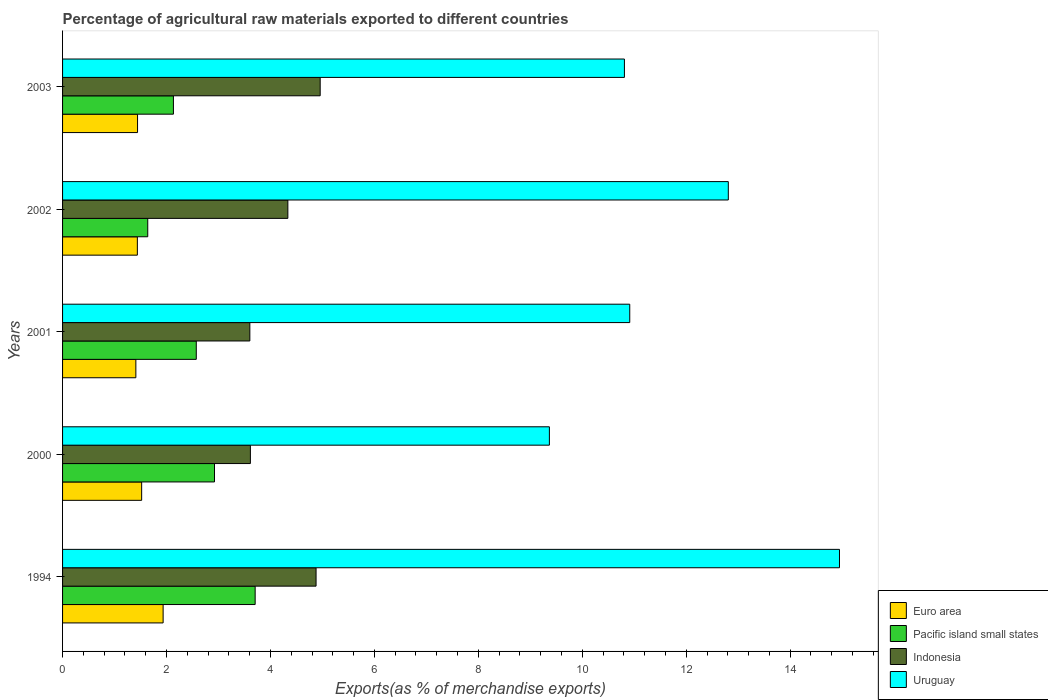How many different coloured bars are there?
Keep it short and to the point. 4. How many groups of bars are there?
Provide a succinct answer. 5. Are the number of bars per tick equal to the number of legend labels?
Keep it short and to the point. Yes. Are the number of bars on each tick of the Y-axis equal?
Offer a terse response. Yes. How many bars are there on the 5th tick from the top?
Make the answer very short. 4. What is the label of the 1st group of bars from the top?
Your answer should be compact. 2003. What is the percentage of exports to different countries in Uruguay in 2002?
Offer a very short reply. 12.81. Across all years, what is the maximum percentage of exports to different countries in Pacific island small states?
Your response must be concise. 3.71. Across all years, what is the minimum percentage of exports to different countries in Uruguay?
Your answer should be compact. 9.37. In which year was the percentage of exports to different countries in Pacific island small states minimum?
Give a very brief answer. 2002. What is the total percentage of exports to different countries in Indonesia in the graph?
Provide a succinct answer. 21.39. What is the difference between the percentage of exports to different countries in Indonesia in 1994 and that in 2001?
Your response must be concise. 1.27. What is the difference between the percentage of exports to different countries in Pacific island small states in 2001 and the percentage of exports to different countries in Indonesia in 2002?
Give a very brief answer. -1.76. What is the average percentage of exports to different countries in Euro area per year?
Your response must be concise. 1.55. In the year 2002, what is the difference between the percentage of exports to different countries in Indonesia and percentage of exports to different countries in Uruguay?
Your answer should be compact. -8.47. In how many years, is the percentage of exports to different countries in Indonesia greater than 2.4 %?
Offer a terse response. 5. What is the ratio of the percentage of exports to different countries in Pacific island small states in 1994 to that in 2003?
Provide a succinct answer. 1.74. Is the percentage of exports to different countries in Indonesia in 1994 less than that in 2001?
Your answer should be compact. No. What is the difference between the highest and the second highest percentage of exports to different countries in Indonesia?
Your response must be concise. 0.08. What is the difference between the highest and the lowest percentage of exports to different countries in Pacific island small states?
Give a very brief answer. 2.07. In how many years, is the percentage of exports to different countries in Indonesia greater than the average percentage of exports to different countries in Indonesia taken over all years?
Offer a very short reply. 3. What does the 3rd bar from the top in 2001 represents?
Keep it short and to the point. Pacific island small states. What does the 4th bar from the bottom in 2003 represents?
Give a very brief answer. Uruguay. How many years are there in the graph?
Offer a very short reply. 5. What is the difference between two consecutive major ticks on the X-axis?
Your answer should be compact. 2. Are the values on the major ticks of X-axis written in scientific E-notation?
Your answer should be compact. No. How many legend labels are there?
Make the answer very short. 4. What is the title of the graph?
Offer a terse response. Percentage of agricultural raw materials exported to different countries. Does "New Caledonia" appear as one of the legend labels in the graph?
Your response must be concise. No. What is the label or title of the X-axis?
Provide a succinct answer. Exports(as % of merchandise exports). What is the Exports(as % of merchandise exports) of Euro area in 1994?
Offer a terse response. 1.93. What is the Exports(as % of merchandise exports) in Pacific island small states in 1994?
Provide a succinct answer. 3.71. What is the Exports(as % of merchandise exports) in Indonesia in 1994?
Provide a short and direct response. 4.88. What is the Exports(as % of merchandise exports) of Uruguay in 1994?
Your response must be concise. 14.95. What is the Exports(as % of merchandise exports) in Euro area in 2000?
Ensure brevity in your answer.  1.52. What is the Exports(as % of merchandise exports) of Pacific island small states in 2000?
Give a very brief answer. 2.92. What is the Exports(as % of merchandise exports) of Indonesia in 2000?
Give a very brief answer. 3.61. What is the Exports(as % of merchandise exports) in Uruguay in 2000?
Ensure brevity in your answer.  9.37. What is the Exports(as % of merchandise exports) of Euro area in 2001?
Offer a very short reply. 1.41. What is the Exports(as % of merchandise exports) of Pacific island small states in 2001?
Make the answer very short. 2.57. What is the Exports(as % of merchandise exports) of Indonesia in 2001?
Your answer should be very brief. 3.6. What is the Exports(as % of merchandise exports) in Uruguay in 2001?
Give a very brief answer. 10.91. What is the Exports(as % of merchandise exports) in Euro area in 2002?
Give a very brief answer. 1.44. What is the Exports(as % of merchandise exports) of Pacific island small states in 2002?
Give a very brief answer. 1.64. What is the Exports(as % of merchandise exports) in Indonesia in 2002?
Ensure brevity in your answer.  4.33. What is the Exports(as % of merchandise exports) of Uruguay in 2002?
Your response must be concise. 12.81. What is the Exports(as % of merchandise exports) of Euro area in 2003?
Ensure brevity in your answer.  1.44. What is the Exports(as % of merchandise exports) in Pacific island small states in 2003?
Your answer should be very brief. 2.13. What is the Exports(as % of merchandise exports) in Indonesia in 2003?
Offer a very short reply. 4.96. What is the Exports(as % of merchandise exports) in Uruguay in 2003?
Offer a very short reply. 10.81. Across all years, what is the maximum Exports(as % of merchandise exports) in Euro area?
Provide a short and direct response. 1.93. Across all years, what is the maximum Exports(as % of merchandise exports) in Pacific island small states?
Provide a succinct answer. 3.71. Across all years, what is the maximum Exports(as % of merchandise exports) of Indonesia?
Keep it short and to the point. 4.96. Across all years, what is the maximum Exports(as % of merchandise exports) of Uruguay?
Your response must be concise. 14.95. Across all years, what is the minimum Exports(as % of merchandise exports) in Euro area?
Offer a very short reply. 1.41. Across all years, what is the minimum Exports(as % of merchandise exports) in Pacific island small states?
Your answer should be very brief. 1.64. Across all years, what is the minimum Exports(as % of merchandise exports) in Indonesia?
Offer a terse response. 3.6. Across all years, what is the minimum Exports(as % of merchandise exports) of Uruguay?
Offer a terse response. 9.37. What is the total Exports(as % of merchandise exports) of Euro area in the graph?
Keep it short and to the point. 7.75. What is the total Exports(as % of merchandise exports) in Pacific island small states in the graph?
Keep it short and to the point. 12.97. What is the total Exports(as % of merchandise exports) of Indonesia in the graph?
Offer a terse response. 21.39. What is the total Exports(as % of merchandise exports) of Uruguay in the graph?
Your answer should be very brief. 58.85. What is the difference between the Exports(as % of merchandise exports) of Euro area in 1994 and that in 2000?
Offer a very short reply. 0.41. What is the difference between the Exports(as % of merchandise exports) in Pacific island small states in 1994 and that in 2000?
Provide a succinct answer. 0.78. What is the difference between the Exports(as % of merchandise exports) of Indonesia in 1994 and that in 2000?
Your answer should be compact. 1.26. What is the difference between the Exports(as % of merchandise exports) of Uruguay in 1994 and that in 2000?
Your response must be concise. 5.58. What is the difference between the Exports(as % of merchandise exports) in Euro area in 1994 and that in 2001?
Make the answer very short. 0.52. What is the difference between the Exports(as % of merchandise exports) of Pacific island small states in 1994 and that in 2001?
Provide a short and direct response. 1.13. What is the difference between the Exports(as % of merchandise exports) in Indonesia in 1994 and that in 2001?
Your answer should be very brief. 1.27. What is the difference between the Exports(as % of merchandise exports) of Uruguay in 1994 and that in 2001?
Offer a terse response. 4.04. What is the difference between the Exports(as % of merchandise exports) of Euro area in 1994 and that in 2002?
Provide a short and direct response. 0.5. What is the difference between the Exports(as % of merchandise exports) of Pacific island small states in 1994 and that in 2002?
Keep it short and to the point. 2.07. What is the difference between the Exports(as % of merchandise exports) of Indonesia in 1994 and that in 2002?
Ensure brevity in your answer.  0.54. What is the difference between the Exports(as % of merchandise exports) of Uruguay in 1994 and that in 2002?
Offer a terse response. 2.14. What is the difference between the Exports(as % of merchandise exports) in Euro area in 1994 and that in 2003?
Your answer should be very brief. 0.49. What is the difference between the Exports(as % of merchandise exports) of Pacific island small states in 1994 and that in 2003?
Provide a succinct answer. 1.57. What is the difference between the Exports(as % of merchandise exports) of Indonesia in 1994 and that in 2003?
Keep it short and to the point. -0.08. What is the difference between the Exports(as % of merchandise exports) in Uruguay in 1994 and that in 2003?
Keep it short and to the point. 4.14. What is the difference between the Exports(as % of merchandise exports) of Euro area in 2000 and that in 2001?
Offer a very short reply. 0.11. What is the difference between the Exports(as % of merchandise exports) of Pacific island small states in 2000 and that in 2001?
Ensure brevity in your answer.  0.35. What is the difference between the Exports(as % of merchandise exports) in Indonesia in 2000 and that in 2001?
Offer a terse response. 0.01. What is the difference between the Exports(as % of merchandise exports) of Uruguay in 2000 and that in 2001?
Offer a very short reply. -1.55. What is the difference between the Exports(as % of merchandise exports) of Euro area in 2000 and that in 2002?
Your response must be concise. 0.08. What is the difference between the Exports(as % of merchandise exports) in Pacific island small states in 2000 and that in 2002?
Your response must be concise. 1.28. What is the difference between the Exports(as % of merchandise exports) of Indonesia in 2000 and that in 2002?
Provide a succinct answer. -0.72. What is the difference between the Exports(as % of merchandise exports) of Uruguay in 2000 and that in 2002?
Provide a succinct answer. -3.44. What is the difference between the Exports(as % of merchandise exports) of Euro area in 2000 and that in 2003?
Offer a very short reply. 0.08. What is the difference between the Exports(as % of merchandise exports) in Pacific island small states in 2000 and that in 2003?
Provide a succinct answer. 0.79. What is the difference between the Exports(as % of merchandise exports) in Indonesia in 2000 and that in 2003?
Provide a succinct answer. -1.34. What is the difference between the Exports(as % of merchandise exports) in Uruguay in 2000 and that in 2003?
Give a very brief answer. -1.44. What is the difference between the Exports(as % of merchandise exports) of Euro area in 2001 and that in 2002?
Provide a succinct answer. -0.03. What is the difference between the Exports(as % of merchandise exports) of Pacific island small states in 2001 and that in 2002?
Your answer should be compact. 0.93. What is the difference between the Exports(as % of merchandise exports) in Indonesia in 2001 and that in 2002?
Provide a short and direct response. -0.73. What is the difference between the Exports(as % of merchandise exports) in Uruguay in 2001 and that in 2002?
Your answer should be very brief. -1.9. What is the difference between the Exports(as % of merchandise exports) of Euro area in 2001 and that in 2003?
Your response must be concise. -0.03. What is the difference between the Exports(as % of merchandise exports) of Pacific island small states in 2001 and that in 2003?
Your answer should be very brief. 0.44. What is the difference between the Exports(as % of merchandise exports) of Indonesia in 2001 and that in 2003?
Make the answer very short. -1.35. What is the difference between the Exports(as % of merchandise exports) in Uruguay in 2001 and that in 2003?
Provide a short and direct response. 0.1. What is the difference between the Exports(as % of merchandise exports) of Euro area in 2002 and that in 2003?
Your answer should be very brief. -0. What is the difference between the Exports(as % of merchandise exports) of Pacific island small states in 2002 and that in 2003?
Provide a short and direct response. -0.49. What is the difference between the Exports(as % of merchandise exports) in Indonesia in 2002 and that in 2003?
Keep it short and to the point. -0.62. What is the difference between the Exports(as % of merchandise exports) of Uruguay in 2002 and that in 2003?
Give a very brief answer. 2. What is the difference between the Exports(as % of merchandise exports) in Euro area in 1994 and the Exports(as % of merchandise exports) in Pacific island small states in 2000?
Keep it short and to the point. -0.99. What is the difference between the Exports(as % of merchandise exports) in Euro area in 1994 and the Exports(as % of merchandise exports) in Indonesia in 2000?
Your answer should be compact. -1.68. What is the difference between the Exports(as % of merchandise exports) in Euro area in 1994 and the Exports(as % of merchandise exports) in Uruguay in 2000?
Ensure brevity in your answer.  -7.43. What is the difference between the Exports(as % of merchandise exports) in Pacific island small states in 1994 and the Exports(as % of merchandise exports) in Indonesia in 2000?
Give a very brief answer. 0.09. What is the difference between the Exports(as % of merchandise exports) of Pacific island small states in 1994 and the Exports(as % of merchandise exports) of Uruguay in 2000?
Provide a succinct answer. -5.66. What is the difference between the Exports(as % of merchandise exports) of Indonesia in 1994 and the Exports(as % of merchandise exports) of Uruguay in 2000?
Ensure brevity in your answer.  -4.49. What is the difference between the Exports(as % of merchandise exports) of Euro area in 1994 and the Exports(as % of merchandise exports) of Pacific island small states in 2001?
Provide a succinct answer. -0.64. What is the difference between the Exports(as % of merchandise exports) of Euro area in 1994 and the Exports(as % of merchandise exports) of Indonesia in 2001?
Keep it short and to the point. -1.67. What is the difference between the Exports(as % of merchandise exports) in Euro area in 1994 and the Exports(as % of merchandise exports) in Uruguay in 2001?
Offer a terse response. -8.98. What is the difference between the Exports(as % of merchandise exports) in Pacific island small states in 1994 and the Exports(as % of merchandise exports) in Indonesia in 2001?
Keep it short and to the point. 0.1. What is the difference between the Exports(as % of merchandise exports) in Pacific island small states in 1994 and the Exports(as % of merchandise exports) in Uruguay in 2001?
Make the answer very short. -7.21. What is the difference between the Exports(as % of merchandise exports) in Indonesia in 1994 and the Exports(as % of merchandise exports) in Uruguay in 2001?
Provide a succinct answer. -6.04. What is the difference between the Exports(as % of merchandise exports) in Euro area in 1994 and the Exports(as % of merchandise exports) in Pacific island small states in 2002?
Keep it short and to the point. 0.3. What is the difference between the Exports(as % of merchandise exports) of Euro area in 1994 and the Exports(as % of merchandise exports) of Indonesia in 2002?
Give a very brief answer. -2.4. What is the difference between the Exports(as % of merchandise exports) in Euro area in 1994 and the Exports(as % of merchandise exports) in Uruguay in 2002?
Provide a short and direct response. -10.87. What is the difference between the Exports(as % of merchandise exports) of Pacific island small states in 1994 and the Exports(as % of merchandise exports) of Indonesia in 2002?
Make the answer very short. -0.63. What is the difference between the Exports(as % of merchandise exports) in Pacific island small states in 1994 and the Exports(as % of merchandise exports) in Uruguay in 2002?
Keep it short and to the point. -9.1. What is the difference between the Exports(as % of merchandise exports) of Indonesia in 1994 and the Exports(as % of merchandise exports) of Uruguay in 2002?
Give a very brief answer. -7.93. What is the difference between the Exports(as % of merchandise exports) of Euro area in 1994 and the Exports(as % of merchandise exports) of Pacific island small states in 2003?
Give a very brief answer. -0.2. What is the difference between the Exports(as % of merchandise exports) in Euro area in 1994 and the Exports(as % of merchandise exports) in Indonesia in 2003?
Your response must be concise. -3.02. What is the difference between the Exports(as % of merchandise exports) in Euro area in 1994 and the Exports(as % of merchandise exports) in Uruguay in 2003?
Your answer should be very brief. -8.88. What is the difference between the Exports(as % of merchandise exports) in Pacific island small states in 1994 and the Exports(as % of merchandise exports) in Indonesia in 2003?
Offer a terse response. -1.25. What is the difference between the Exports(as % of merchandise exports) of Pacific island small states in 1994 and the Exports(as % of merchandise exports) of Uruguay in 2003?
Your answer should be compact. -7.1. What is the difference between the Exports(as % of merchandise exports) of Indonesia in 1994 and the Exports(as % of merchandise exports) of Uruguay in 2003?
Make the answer very short. -5.93. What is the difference between the Exports(as % of merchandise exports) of Euro area in 2000 and the Exports(as % of merchandise exports) of Pacific island small states in 2001?
Your answer should be very brief. -1.05. What is the difference between the Exports(as % of merchandise exports) in Euro area in 2000 and the Exports(as % of merchandise exports) in Indonesia in 2001?
Provide a succinct answer. -2.08. What is the difference between the Exports(as % of merchandise exports) in Euro area in 2000 and the Exports(as % of merchandise exports) in Uruguay in 2001?
Offer a terse response. -9.39. What is the difference between the Exports(as % of merchandise exports) in Pacific island small states in 2000 and the Exports(as % of merchandise exports) in Indonesia in 2001?
Provide a short and direct response. -0.68. What is the difference between the Exports(as % of merchandise exports) of Pacific island small states in 2000 and the Exports(as % of merchandise exports) of Uruguay in 2001?
Your answer should be very brief. -7.99. What is the difference between the Exports(as % of merchandise exports) of Indonesia in 2000 and the Exports(as % of merchandise exports) of Uruguay in 2001?
Your answer should be compact. -7.3. What is the difference between the Exports(as % of merchandise exports) of Euro area in 2000 and the Exports(as % of merchandise exports) of Pacific island small states in 2002?
Keep it short and to the point. -0.12. What is the difference between the Exports(as % of merchandise exports) of Euro area in 2000 and the Exports(as % of merchandise exports) of Indonesia in 2002?
Give a very brief answer. -2.81. What is the difference between the Exports(as % of merchandise exports) in Euro area in 2000 and the Exports(as % of merchandise exports) in Uruguay in 2002?
Your response must be concise. -11.29. What is the difference between the Exports(as % of merchandise exports) in Pacific island small states in 2000 and the Exports(as % of merchandise exports) in Indonesia in 2002?
Offer a terse response. -1.41. What is the difference between the Exports(as % of merchandise exports) in Pacific island small states in 2000 and the Exports(as % of merchandise exports) in Uruguay in 2002?
Your answer should be very brief. -9.89. What is the difference between the Exports(as % of merchandise exports) in Indonesia in 2000 and the Exports(as % of merchandise exports) in Uruguay in 2002?
Make the answer very short. -9.2. What is the difference between the Exports(as % of merchandise exports) in Euro area in 2000 and the Exports(as % of merchandise exports) in Pacific island small states in 2003?
Your answer should be compact. -0.61. What is the difference between the Exports(as % of merchandise exports) in Euro area in 2000 and the Exports(as % of merchandise exports) in Indonesia in 2003?
Make the answer very short. -3.43. What is the difference between the Exports(as % of merchandise exports) in Euro area in 2000 and the Exports(as % of merchandise exports) in Uruguay in 2003?
Offer a very short reply. -9.29. What is the difference between the Exports(as % of merchandise exports) of Pacific island small states in 2000 and the Exports(as % of merchandise exports) of Indonesia in 2003?
Offer a very short reply. -2.03. What is the difference between the Exports(as % of merchandise exports) in Pacific island small states in 2000 and the Exports(as % of merchandise exports) in Uruguay in 2003?
Give a very brief answer. -7.89. What is the difference between the Exports(as % of merchandise exports) in Indonesia in 2000 and the Exports(as % of merchandise exports) in Uruguay in 2003?
Keep it short and to the point. -7.2. What is the difference between the Exports(as % of merchandise exports) in Euro area in 2001 and the Exports(as % of merchandise exports) in Pacific island small states in 2002?
Offer a very short reply. -0.23. What is the difference between the Exports(as % of merchandise exports) in Euro area in 2001 and the Exports(as % of merchandise exports) in Indonesia in 2002?
Give a very brief answer. -2.92. What is the difference between the Exports(as % of merchandise exports) of Euro area in 2001 and the Exports(as % of merchandise exports) of Uruguay in 2002?
Your answer should be compact. -11.4. What is the difference between the Exports(as % of merchandise exports) of Pacific island small states in 2001 and the Exports(as % of merchandise exports) of Indonesia in 2002?
Your answer should be very brief. -1.76. What is the difference between the Exports(as % of merchandise exports) of Pacific island small states in 2001 and the Exports(as % of merchandise exports) of Uruguay in 2002?
Your response must be concise. -10.24. What is the difference between the Exports(as % of merchandise exports) in Indonesia in 2001 and the Exports(as % of merchandise exports) in Uruguay in 2002?
Your response must be concise. -9.21. What is the difference between the Exports(as % of merchandise exports) of Euro area in 2001 and the Exports(as % of merchandise exports) of Pacific island small states in 2003?
Your response must be concise. -0.72. What is the difference between the Exports(as % of merchandise exports) in Euro area in 2001 and the Exports(as % of merchandise exports) in Indonesia in 2003?
Offer a terse response. -3.55. What is the difference between the Exports(as % of merchandise exports) in Euro area in 2001 and the Exports(as % of merchandise exports) in Uruguay in 2003?
Your answer should be very brief. -9.4. What is the difference between the Exports(as % of merchandise exports) in Pacific island small states in 2001 and the Exports(as % of merchandise exports) in Indonesia in 2003?
Your answer should be compact. -2.38. What is the difference between the Exports(as % of merchandise exports) in Pacific island small states in 2001 and the Exports(as % of merchandise exports) in Uruguay in 2003?
Offer a terse response. -8.24. What is the difference between the Exports(as % of merchandise exports) of Indonesia in 2001 and the Exports(as % of merchandise exports) of Uruguay in 2003?
Offer a very short reply. -7.21. What is the difference between the Exports(as % of merchandise exports) in Euro area in 2002 and the Exports(as % of merchandise exports) in Pacific island small states in 2003?
Your answer should be very brief. -0.69. What is the difference between the Exports(as % of merchandise exports) of Euro area in 2002 and the Exports(as % of merchandise exports) of Indonesia in 2003?
Provide a short and direct response. -3.52. What is the difference between the Exports(as % of merchandise exports) in Euro area in 2002 and the Exports(as % of merchandise exports) in Uruguay in 2003?
Keep it short and to the point. -9.37. What is the difference between the Exports(as % of merchandise exports) of Pacific island small states in 2002 and the Exports(as % of merchandise exports) of Indonesia in 2003?
Make the answer very short. -3.32. What is the difference between the Exports(as % of merchandise exports) in Pacific island small states in 2002 and the Exports(as % of merchandise exports) in Uruguay in 2003?
Your answer should be compact. -9.17. What is the difference between the Exports(as % of merchandise exports) of Indonesia in 2002 and the Exports(as % of merchandise exports) of Uruguay in 2003?
Provide a succinct answer. -6.48. What is the average Exports(as % of merchandise exports) of Euro area per year?
Provide a short and direct response. 1.55. What is the average Exports(as % of merchandise exports) of Pacific island small states per year?
Keep it short and to the point. 2.59. What is the average Exports(as % of merchandise exports) in Indonesia per year?
Offer a terse response. 4.28. What is the average Exports(as % of merchandise exports) in Uruguay per year?
Your answer should be compact. 11.77. In the year 1994, what is the difference between the Exports(as % of merchandise exports) in Euro area and Exports(as % of merchandise exports) in Pacific island small states?
Give a very brief answer. -1.77. In the year 1994, what is the difference between the Exports(as % of merchandise exports) in Euro area and Exports(as % of merchandise exports) in Indonesia?
Offer a very short reply. -2.94. In the year 1994, what is the difference between the Exports(as % of merchandise exports) in Euro area and Exports(as % of merchandise exports) in Uruguay?
Offer a very short reply. -13.01. In the year 1994, what is the difference between the Exports(as % of merchandise exports) in Pacific island small states and Exports(as % of merchandise exports) in Indonesia?
Provide a succinct answer. -1.17. In the year 1994, what is the difference between the Exports(as % of merchandise exports) of Pacific island small states and Exports(as % of merchandise exports) of Uruguay?
Offer a terse response. -11.24. In the year 1994, what is the difference between the Exports(as % of merchandise exports) of Indonesia and Exports(as % of merchandise exports) of Uruguay?
Provide a short and direct response. -10.07. In the year 2000, what is the difference between the Exports(as % of merchandise exports) of Euro area and Exports(as % of merchandise exports) of Pacific island small states?
Offer a terse response. -1.4. In the year 2000, what is the difference between the Exports(as % of merchandise exports) in Euro area and Exports(as % of merchandise exports) in Indonesia?
Make the answer very short. -2.09. In the year 2000, what is the difference between the Exports(as % of merchandise exports) of Euro area and Exports(as % of merchandise exports) of Uruguay?
Your answer should be compact. -7.84. In the year 2000, what is the difference between the Exports(as % of merchandise exports) of Pacific island small states and Exports(as % of merchandise exports) of Indonesia?
Your response must be concise. -0.69. In the year 2000, what is the difference between the Exports(as % of merchandise exports) of Pacific island small states and Exports(as % of merchandise exports) of Uruguay?
Make the answer very short. -6.44. In the year 2000, what is the difference between the Exports(as % of merchandise exports) of Indonesia and Exports(as % of merchandise exports) of Uruguay?
Your answer should be very brief. -5.75. In the year 2001, what is the difference between the Exports(as % of merchandise exports) of Euro area and Exports(as % of merchandise exports) of Pacific island small states?
Ensure brevity in your answer.  -1.16. In the year 2001, what is the difference between the Exports(as % of merchandise exports) of Euro area and Exports(as % of merchandise exports) of Indonesia?
Ensure brevity in your answer.  -2.19. In the year 2001, what is the difference between the Exports(as % of merchandise exports) in Euro area and Exports(as % of merchandise exports) in Uruguay?
Ensure brevity in your answer.  -9.5. In the year 2001, what is the difference between the Exports(as % of merchandise exports) of Pacific island small states and Exports(as % of merchandise exports) of Indonesia?
Your response must be concise. -1.03. In the year 2001, what is the difference between the Exports(as % of merchandise exports) of Pacific island small states and Exports(as % of merchandise exports) of Uruguay?
Ensure brevity in your answer.  -8.34. In the year 2001, what is the difference between the Exports(as % of merchandise exports) in Indonesia and Exports(as % of merchandise exports) in Uruguay?
Provide a succinct answer. -7.31. In the year 2002, what is the difference between the Exports(as % of merchandise exports) in Euro area and Exports(as % of merchandise exports) in Pacific island small states?
Give a very brief answer. -0.2. In the year 2002, what is the difference between the Exports(as % of merchandise exports) of Euro area and Exports(as % of merchandise exports) of Indonesia?
Your answer should be very brief. -2.9. In the year 2002, what is the difference between the Exports(as % of merchandise exports) in Euro area and Exports(as % of merchandise exports) in Uruguay?
Your answer should be compact. -11.37. In the year 2002, what is the difference between the Exports(as % of merchandise exports) in Pacific island small states and Exports(as % of merchandise exports) in Indonesia?
Ensure brevity in your answer.  -2.7. In the year 2002, what is the difference between the Exports(as % of merchandise exports) in Pacific island small states and Exports(as % of merchandise exports) in Uruguay?
Offer a very short reply. -11.17. In the year 2002, what is the difference between the Exports(as % of merchandise exports) in Indonesia and Exports(as % of merchandise exports) in Uruguay?
Offer a very short reply. -8.47. In the year 2003, what is the difference between the Exports(as % of merchandise exports) in Euro area and Exports(as % of merchandise exports) in Pacific island small states?
Your answer should be very brief. -0.69. In the year 2003, what is the difference between the Exports(as % of merchandise exports) of Euro area and Exports(as % of merchandise exports) of Indonesia?
Offer a very short reply. -3.51. In the year 2003, what is the difference between the Exports(as % of merchandise exports) in Euro area and Exports(as % of merchandise exports) in Uruguay?
Make the answer very short. -9.37. In the year 2003, what is the difference between the Exports(as % of merchandise exports) of Pacific island small states and Exports(as % of merchandise exports) of Indonesia?
Offer a terse response. -2.82. In the year 2003, what is the difference between the Exports(as % of merchandise exports) of Pacific island small states and Exports(as % of merchandise exports) of Uruguay?
Offer a terse response. -8.68. In the year 2003, what is the difference between the Exports(as % of merchandise exports) of Indonesia and Exports(as % of merchandise exports) of Uruguay?
Offer a very short reply. -5.85. What is the ratio of the Exports(as % of merchandise exports) of Euro area in 1994 to that in 2000?
Your answer should be very brief. 1.27. What is the ratio of the Exports(as % of merchandise exports) of Pacific island small states in 1994 to that in 2000?
Your answer should be very brief. 1.27. What is the ratio of the Exports(as % of merchandise exports) of Indonesia in 1994 to that in 2000?
Your answer should be compact. 1.35. What is the ratio of the Exports(as % of merchandise exports) in Uruguay in 1994 to that in 2000?
Your response must be concise. 1.6. What is the ratio of the Exports(as % of merchandise exports) in Euro area in 1994 to that in 2001?
Your answer should be compact. 1.37. What is the ratio of the Exports(as % of merchandise exports) in Pacific island small states in 1994 to that in 2001?
Keep it short and to the point. 1.44. What is the ratio of the Exports(as % of merchandise exports) of Indonesia in 1994 to that in 2001?
Offer a terse response. 1.35. What is the ratio of the Exports(as % of merchandise exports) in Uruguay in 1994 to that in 2001?
Your answer should be compact. 1.37. What is the ratio of the Exports(as % of merchandise exports) of Euro area in 1994 to that in 2002?
Your answer should be compact. 1.34. What is the ratio of the Exports(as % of merchandise exports) of Pacific island small states in 1994 to that in 2002?
Your answer should be very brief. 2.26. What is the ratio of the Exports(as % of merchandise exports) in Indonesia in 1994 to that in 2002?
Provide a short and direct response. 1.13. What is the ratio of the Exports(as % of merchandise exports) in Uruguay in 1994 to that in 2002?
Keep it short and to the point. 1.17. What is the ratio of the Exports(as % of merchandise exports) of Euro area in 1994 to that in 2003?
Your answer should be compact. 1.34. What is the ratio of the Exports(as % of merchandise exports) of Pacific island small states in 1994 to that in 2003?
Keep it short and to the point. 1.74. What is the ratio of the Exports(as % of merchandise exports) of Indonesia in 1994 to that in 2003?
Give a very brief answer. 0.98. What is the ratio of the Exports(as % of merchandise exports) in Uruguay in 1994 to that in 2003?
Make the answer very short. 1.38. What is the ratio of the Exports(as % of merchandise exports) of Euro area in 2000 to that in 2001?
Your answer should be compact. 1.08. What is the ratio of the Exports(as % of merchandise exports) in Pacific island small states in 2000 to that in 2001?
Provide a short and direct response. 1.14. What is the ratio of the Exports(as % of merchandise exports) of Uruguay in 2000 to that in 2001?
Ensure brevity in your answer.  0.86. What is the ratio of the Exports(as % of merchandise exports) in Euro area in 2000 to that in 2002?
Offer a terse response. 1.06. What is the ratio of the Exports(as % of merchandise exports) of Pacific island small states in 2000 to that in 2002?
Your response must be concise. 1.78. What is the ratio of the Exports(as % of merchandise exports) in Indonesia in 2000 to that in 2002?
Keep it short and to the point. 0.83. What is the ratio of the Exports(as % of merchandise exports) in Uruguay in 2000 to that in 2002?
Provide a short and direct response. 0.73. What is the ratio of the Exports(as % of merchandise exports) in Euro area in 2000 to that in 2003?
Offer a terse response. 1.05. What is the ratio of the Exports(as % of merchandise exports) in Pacific island small states in 2000 to that in 2003?
Ensure brevity in your answer.  1.37. What is the ratio of the Exports(as % of merchandise exports) of Indonesia in 2000 to that in 2003?
Provide a short and direct response. 0.73. What is the ratio of the Exports(as % of merchandise exports) of Uruguay in 2000 to that in 2003?
Your response must be concise. 0.87. What is the ratio of the Exports(as % of merchandise exports) of Euro area in 2001 to that in 2002?
Provide a short and direct response. 0.98. What is the ratio of the Exports(as % of merchandise exports) of Pacific island small states in 2001 to that in 2002?
Your answer should be very brief. 1.57. What is the ratio of the Exports(as % of merchandise exports) in Indonesia in 2001 to that in 2002?
Offer a terse response. 0.83. What is the ratio of the Exports(as % of merchandise exports) in Uruguay in 2001 to that in 2002?
Provide a short and direct response. 0.85. What is the ratio of the Exports(as % of merchandise exports) of Euro area in 2001 to that in 2003?
Offer a very short reply. 0.98. What is the ratio of the Exports(as % of merchandise exports) of Pacific island small states in 2001 to that in 2003?
Ensure brevity in your answer.  1.21. What is the ratio of the Exports(as % of merchandise exports) in Indonesia in 2001 to that in 2003?
Provide a short and direct response. 0.73. What is the ratio of the Exports(as % of merchandise exports) in Uruguay in 2001 to that in 2003?
Give a very brief answer. 1.01. What is the ratio of the Exports(as % of merchandise exports) in Euro area in 2002 to that in 2003?
Provide a succinct answer. 1. What is the ratio of the Exports(as % of merchandise exports) in Pacific island small states in 2002 to that in 2003?
Your answer should be compact. 0.77. What is the ratio of the Exports(as % of merchandise exports) of Indonesia in 2002 to that in 2003?
Give a very brief answer. 0.87. What is the ratio of the Exports(as % of merchandise exports) in Uruguay in 2002 to that in 2003?
Give a very brief answer. 1.18. What is the difference between the highest and the second highest Exports(as % of merchandise exports) of Euro area?
Give a very brief answer. 0.41. What is the difference between the highest and the second highest Exports(as % of merchandise exports) of Pacific island small states?
Give a very brief answer. 0.78. What is the difference between the highest and the second highest Exports(as % of merchandise exports) of Indonesia?
Your answer should be compact. 0.08. What is the difference between the highest and the second highest Exports(as % of merchandise exports) of Uruguay?
Your answer should be very brief. 2.14. What is the difference between the highest and the lowest Exports(as % of merchandise exports) in Euro area?
Offer a terse response. 0.52. What is the difference between the highest and the lowest Exports(as % of merchandise exports) of Pacific island small states?
Provide a succinct answer. 2.07. What is the difference between the highest and the lowest Exports(as % of merchandise exports) of Indonesia?
Keep it short and to the point. 1.35. What is the difference between the highest and the lowest Exports(as % of merchandise exports) in Uruguay?
Offer a terse response. 5.58. 